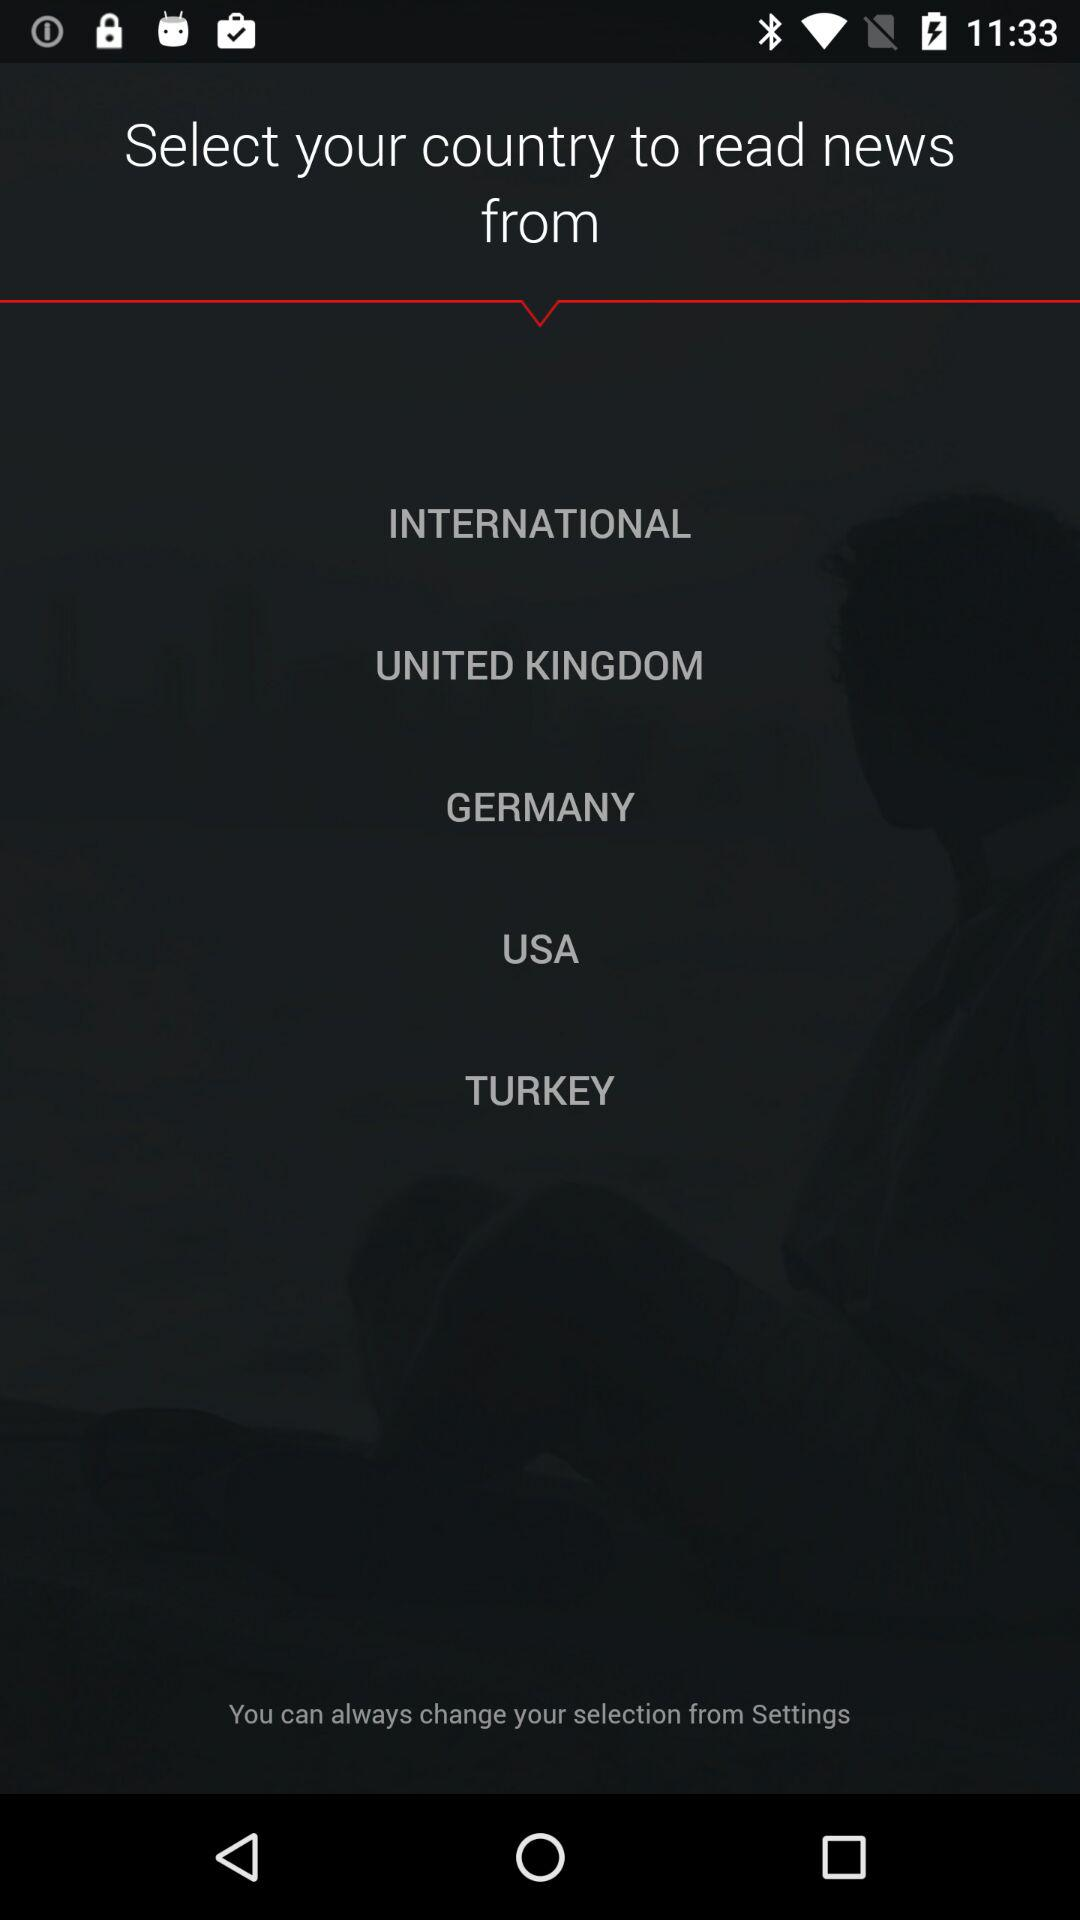How many countries are available to select from?
Answer the question using a single word or phrase. 5 